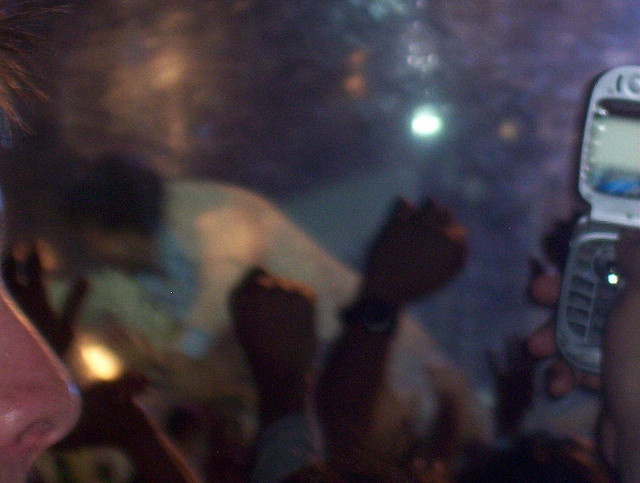Describe the objects in this image and their specific colors. I can see people in black, gray, and purple tones, cell phone in black, darkgray, and gray tones, people in black tones, people in black, maroon, and brown tones, and people in black, maroon, and gray tones in this image. 